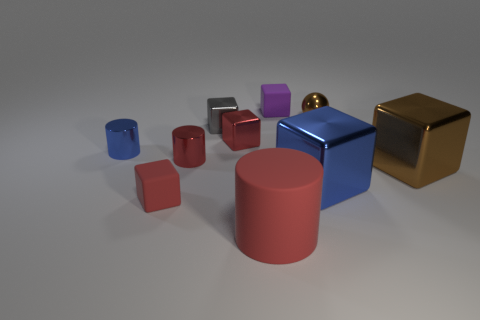There is a cube that is in front of the brown metal block and on the left side of the large blue shiny thing; what is its color? The cube situated in front of the brown metal block and to the left of the large, shiny blue object is red in color, featuring a matte finish which contrasts with the reflective surfaces of the surrounding objects. 